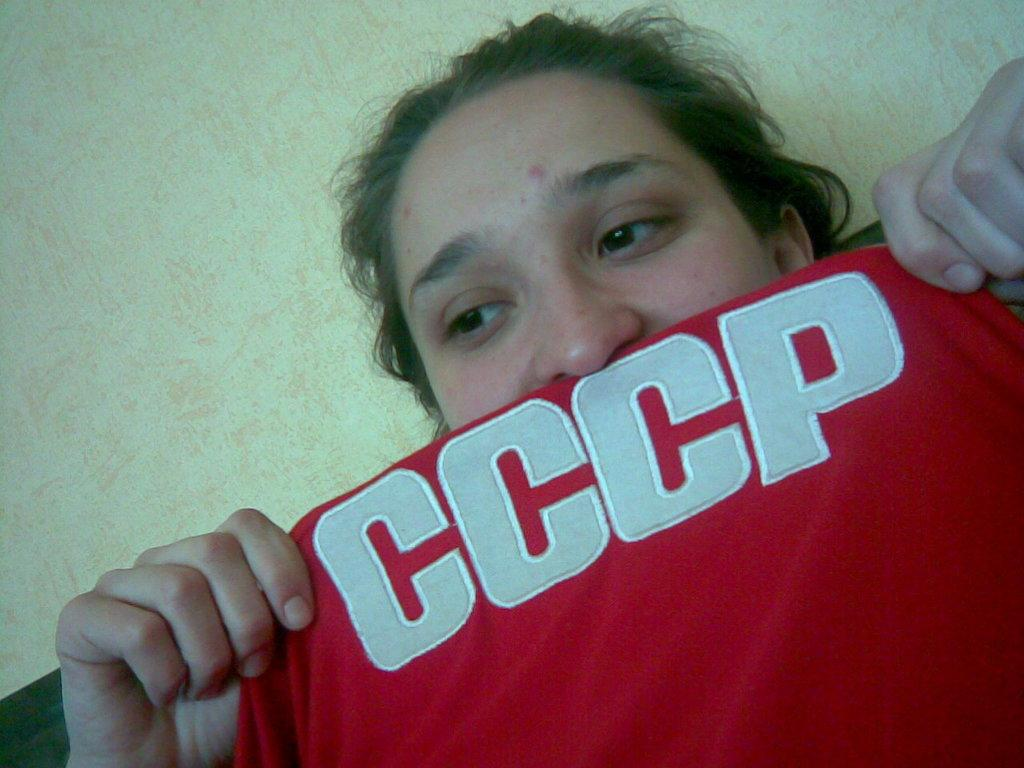Who is present in the image? There is a woman in the image. What is the woman holding in the image? The woman is holding a red T-shirt. What can be seen on the T-shirt? There is text on the T-shirt. What type of teeth can be seen on the branch in the image? There is no branch or teeth present in the image. 